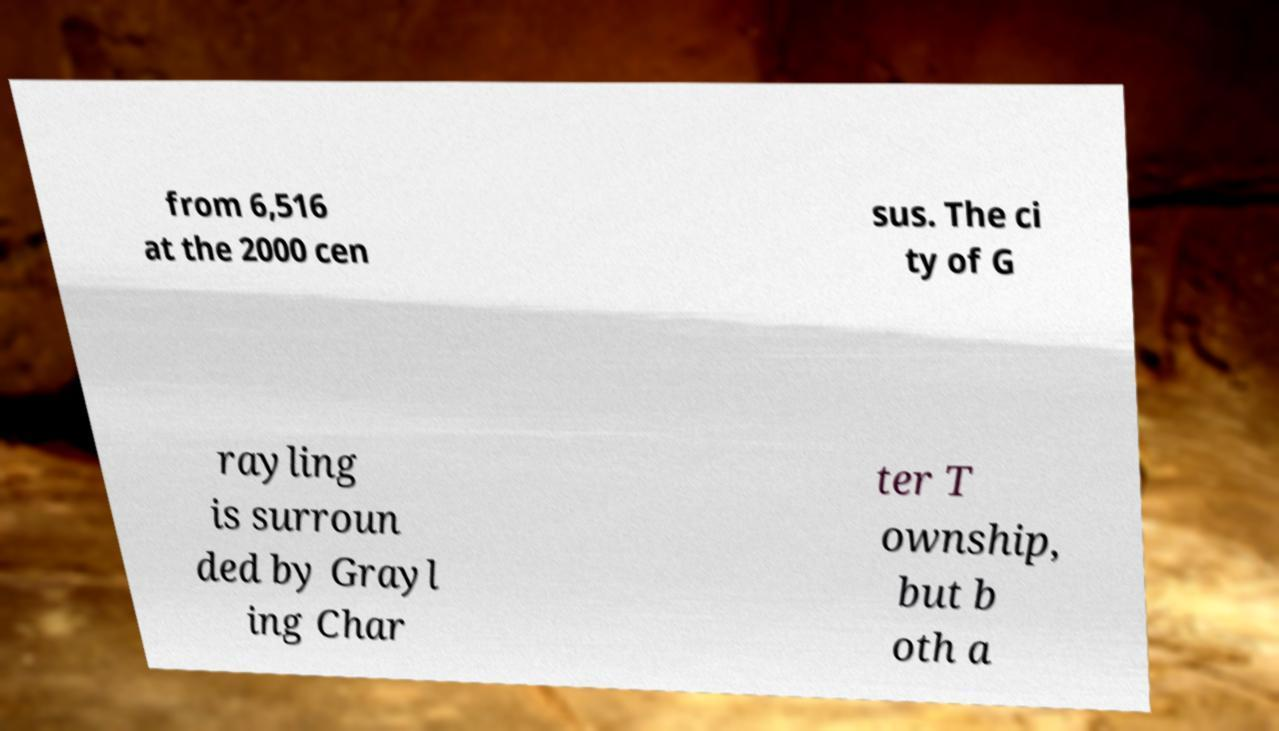Can you read and provide the text displayed in the image?This photo seems to have some interesting text. Can you extract and type it out for me? from 6,516 at the 2000 cen sus. The ci ty of G rayling is surroun ded by Grayl ing Char ter T ownship, but b oth a 